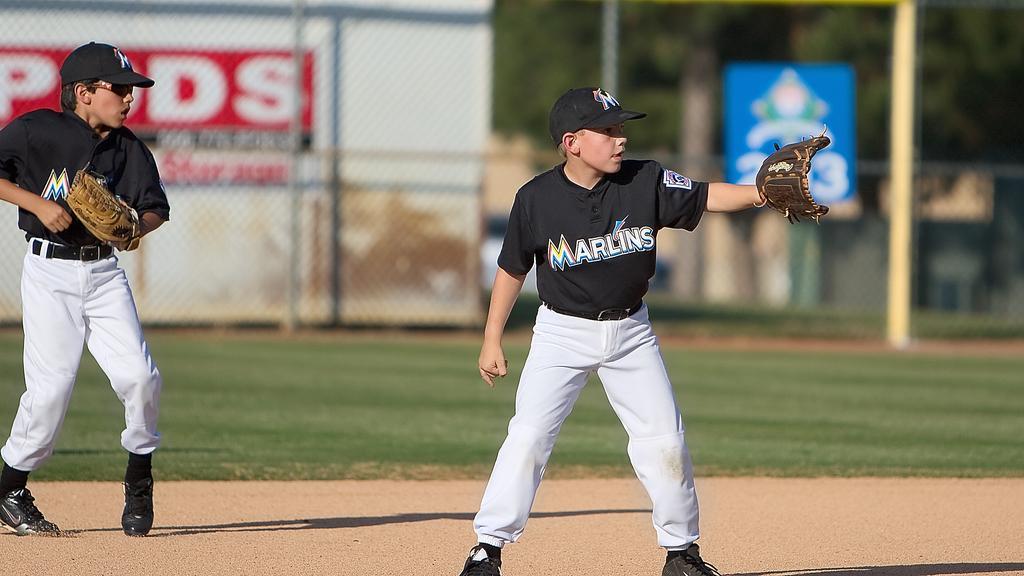In one or two sentences, can you explain what this image depicts? In the foreground, I can see two boys are standing on the ground and are wearing gloves in their hand. In the background, I can see grass, fence, boards, poles and trees. This image might be taken during a day. 